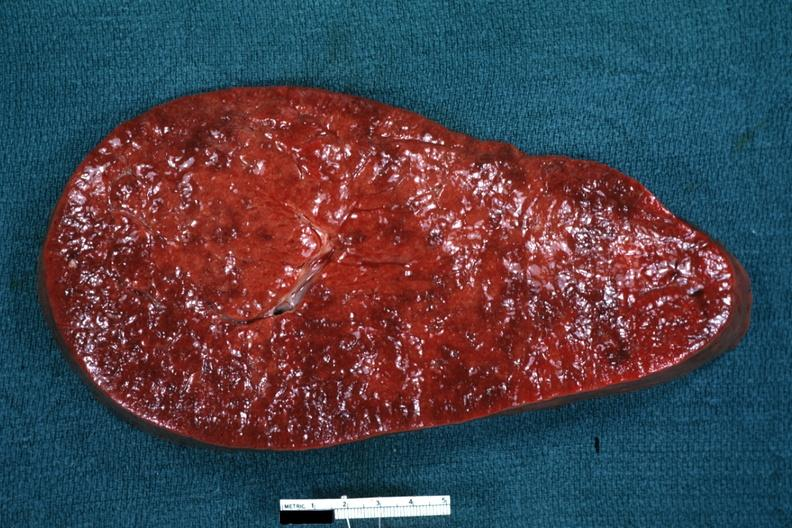does purulent sinusitis show enlarged spleen with rather obvious infiltrate?
Answer the question using a single word or phrase. No 